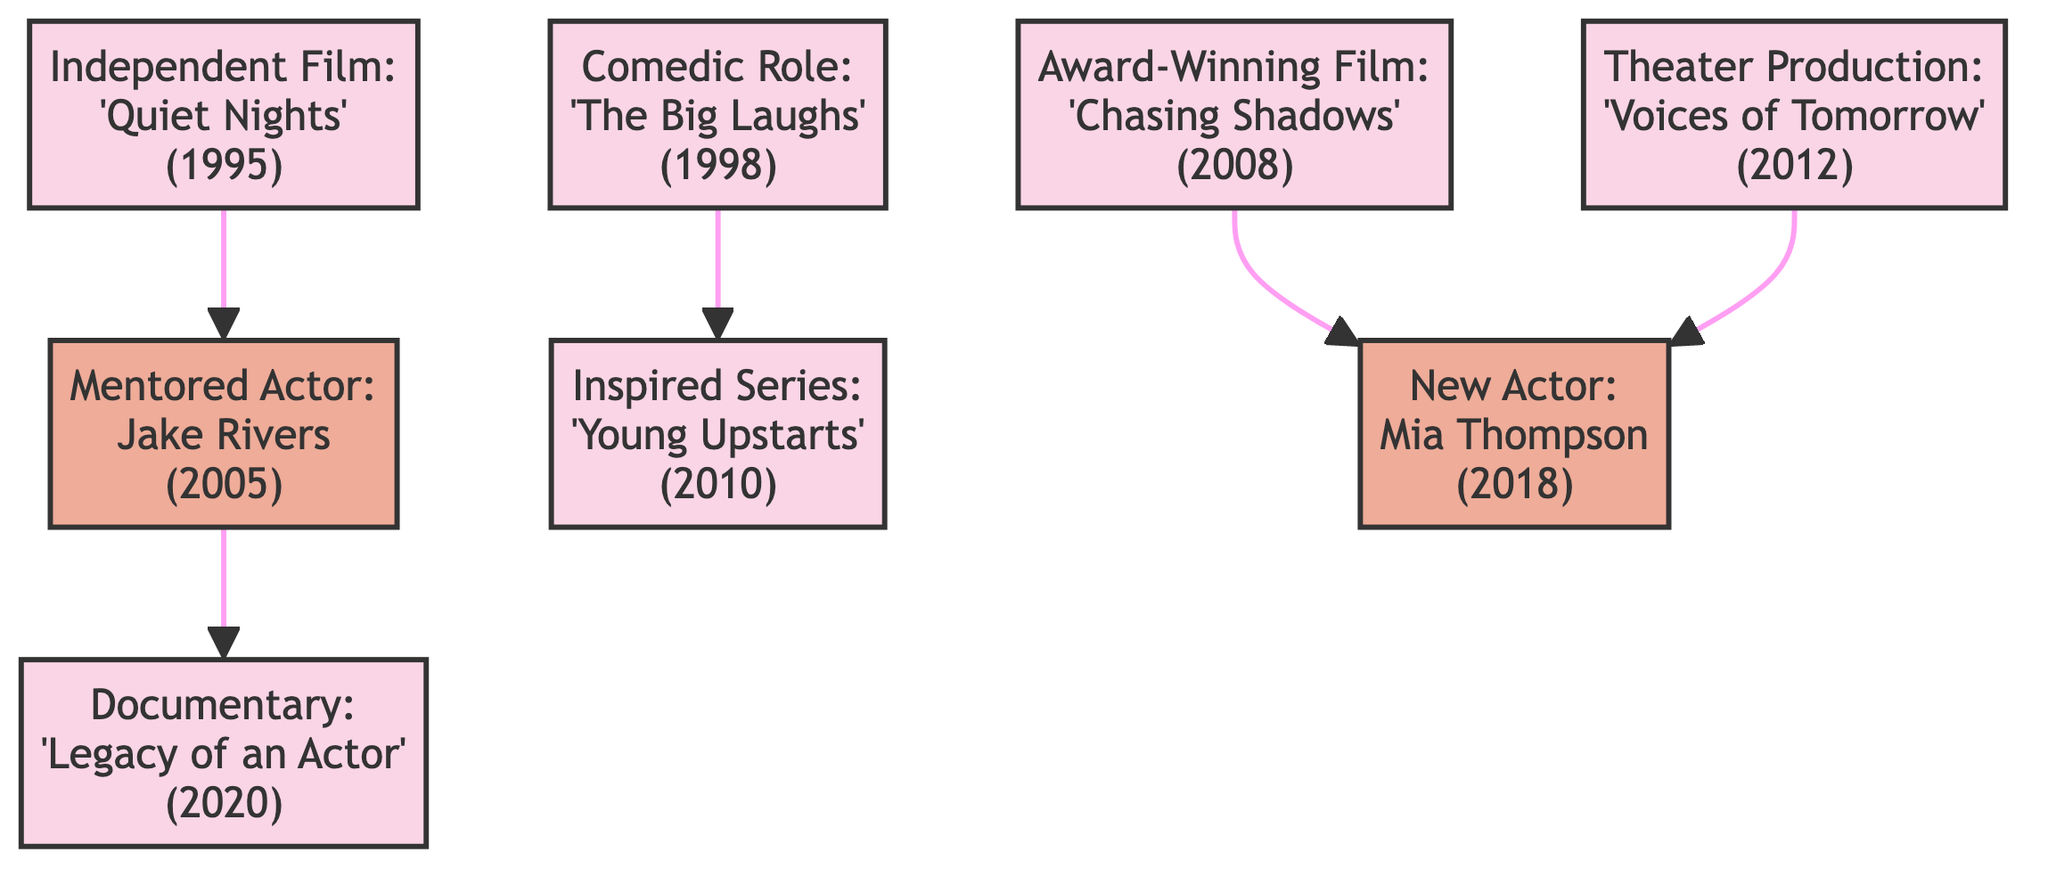What is the year of the project 'Chasing Shadows'? The year associated with the project 'Chasing Shadows' as listed in the diagram is 2008.
Answer: 2008 How many projects are displayed in the diagram? Counting all nodes categorized as 'Project', the diagram lists six projects: 'Quiet Nights', 'The Big Laughs', 'Chasing Shadows', 'Young Upstarts', 'Voices of Tomorrow', and 'Legacy of an Actor'.
Answer: 6 Which influence does 'The Big Laughs' connect to? The connection from 'The Big Laughs' flows to the project 'Young Upstarts', representing the impact of the comedic role on the inspired series.
Answer: Young Upstarts What year was Mia Thompson mentored? The node representing Mia Thompson is linked with the year 2018, indicating the year when she became a new actor influenced by previous productions.
Answer: 2018 What is the connecting influence from 'Quiet Nights'? The project 'Quiet Nights' connects directly to the influence of mentoring Jake Rivers, illustrating how that independent film project had a lasting effect on his career path.
Answer: Jake Rivers Which project influenced Mia Thompson? Mia Thompson is influenced by both 'Chasing Shadows' and 'Voices of Tomorrow', indicating that these projects played a significant role in her artistic development.
Answer: Chasing Shadows, Voices of Tomorrow How many edges are in the diagram? By counting all connections represented as edges between nodes, the diagram illustrates four edges that display the relationships between various projects and influences.
Answer: 5 What is the latest project listed in the diagram? The latest listed project in the diagram is the documentary 'Legacy of an Actor', which showcases the impact of your work over the years and was launched in 2020.
Answer: Legacy of an Actor Which node connects directly to Jake Rivers? The node that connects directly to Jake Rivers is the documentary 'Legacy of an Actor', highlighting how his mentorship influenced the retrospective portrayal of your career.
Answer: Legacy of an Actor 